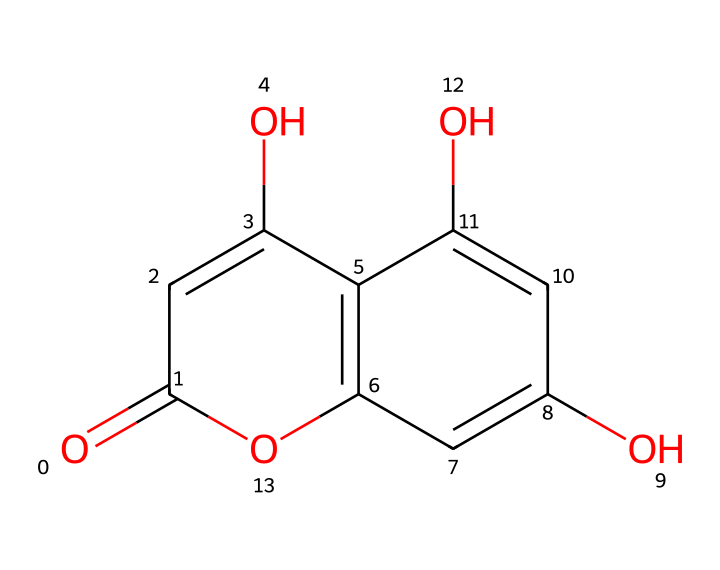What is the main active compound found in chamomile? Based on the provided SMILES structure, the main active compound is indicated in its chemical structure, which corresponds to apigenin.
Answer: apigenin How many hydroxyl groups does apigenin have? By scrutinizing the structure, you can see there are three hydroxyl (-OH) groups represented, which are characteristic of this chemical.
Answer: three What is the molecular formula for apigenin? The molecular formula is derived from the chemical structure; counting all carbon (C), hydrogen (H), and oxygen (O) atoms results in the formula C15H10O5.
Answer: C15H10O5 Is apigenin classified as a flavonoid? The structure reflects that apigenin possesses the basic features of a flavonoid, including two aromatic rings connected by a 3-carbon bridge, signifying its classification.
Answer: yes What type of bond mainly connects the carbon atoms in this chemical? The majority of the carbon atoms in the structure are connected by single (sigma) bonds, with some double bonds (pi bonds), which is typical for organic compounds like apigenin.
Answer: single and double bonds How many rings are present in the structure of apigenin? The analysis of the chemical structure shows that there are three fused rings forming the flavonoid backbone, a characteristic feature of apigenin.
Answer: three 